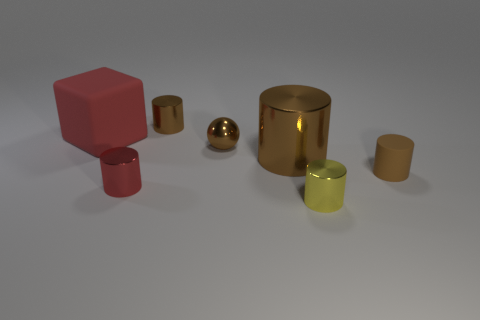How many brown cylinders must be subtracted to get 1 brown cylinders? 2 Subtract all cyan blocks. How many brown cylinders are left? 3 Subtract 2 cylinders. How many cylinders are left? 3 Subtract all big metallic cylinders. How many cylinders are left? 4 Subtract all red cylinders. How many cylinders are left? 4 Subtract all gray cylinders. Subtract all brown blocks. How many cylinders are left? 5 Add 1 spheres. How many objects exist? 8 Subtract all balls. How many objects are left? 6 Add 4 tiny brown metallic objects. How many tiny brown metallic objects are left? 6 Add 4 tiny yellow objects. How many tiny yellow objects exist? 5 